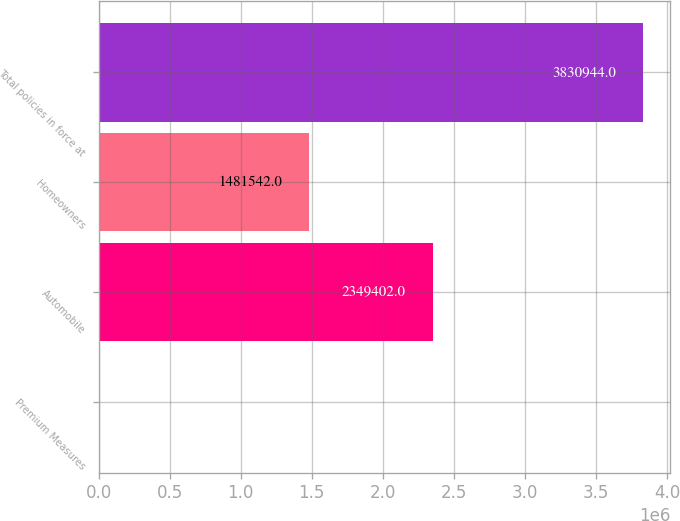Convert chart to OTSL. <chart><loc_0><loc_0><loc_500><loc_500><bar_chart><fcel>Premium Measures<fcel>Automobile<fcel>Homeowners<fcel>Total policies in force at<nl><fcel>2007<fcel>2.3494e+06<fcel>1.48154e+06<fcel>3.83094e+06<nl></chart> 